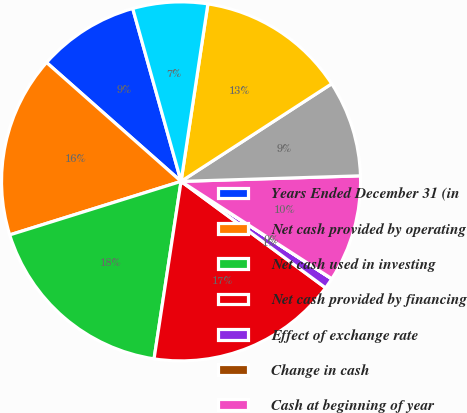<chart> <loc_0><loc_0><loc_500><loc_500><pie_chart><fcel>Years Ended December 31 (in<fcel>Net cash provided by operating<fcel>Net cash used in investing<fcel>Net cash provided by financing<fcel>Effect of exchange rate<fcel>Change in cash<fcel>Cash at beginning of year<fcel>Cash at end of year<fcel>Net income<fcel>Net gains on sales of<nl><fcel>9.14%<fcel>16.34%<fcel>17.78%<fcel>17.3%<fcel>0.97%<fcel>0.01%<fcel>9.62%<fcel>8.66%<fcel>13.46%<fcel>6.73%<nl></chart> 